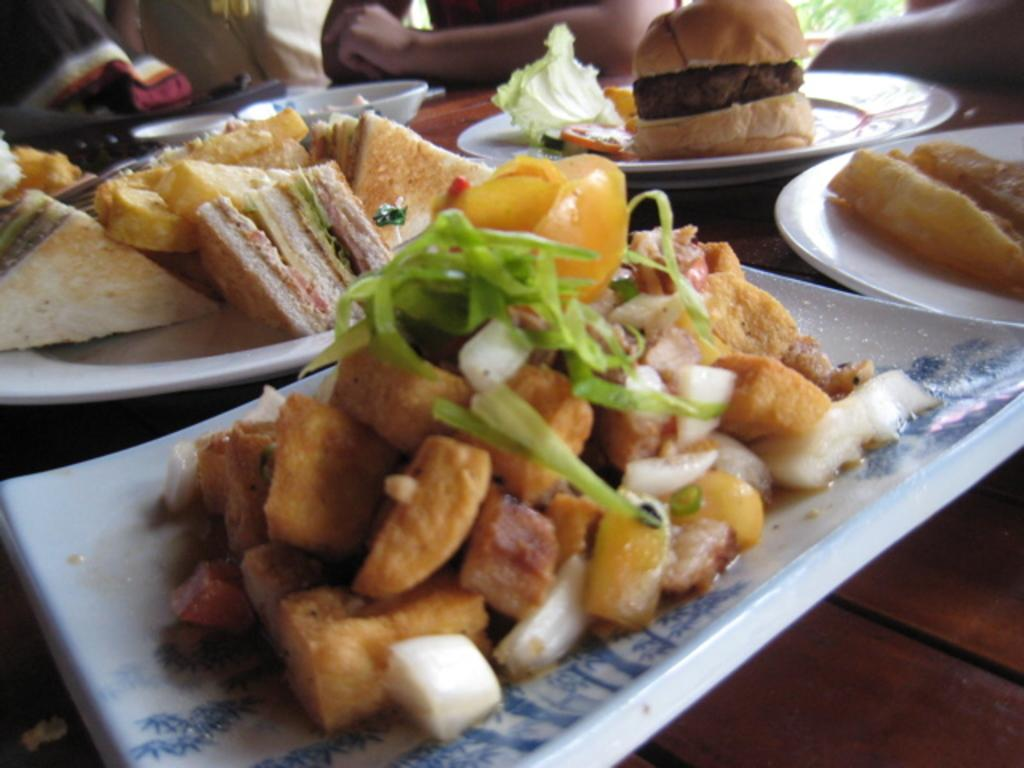What is on the plate that is visible in the image? There are food items served on a plate in the image. Where is the plate located in the image? The plate is placed on a table in the image. Can you describe the people present in the image? Unfortunately, the facts provided do not give any information about the people present in the image. Is the quicksand visible in the image? There is no mention of quicksand in the provided facts, and it is not visible in the image. 